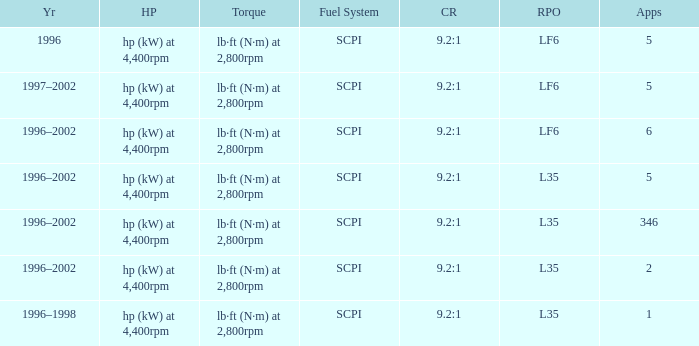What are the torque characteristics of the model made in 1996? Lb·ft (n·m) at 2,800rpm. Could you parse the entire table as a dict? {'header': ['Yr', 'HP', 'Torque', 'Fuel System', 'CR', 'RPO', 'Apps'], 'rows': [['1996', 'hp (kW) at 4,400rpm', 'lb·ft (N·m) at 2,800rpm', 'SCPI', '9.2:1', 'LF6', '5'], ['1997–2002', 'hp (kW) at 4,400rpm', 'lb·ft (N·m) at 2,800rpm', 'SCPI', '9.2:1', 'LF6', '5'], ['1996–2002', 'hp (kW) at 4,400rpm', 'lb·ft (N·m) at 2,800rpm', 'SCPI', '9.2:1', 'LF6', '6'], ['1996–2002', 'hp (kW) at 4,400rpm', 'lb·ft (N·m) at 2,800rpm', 'SCPI', '9.2:1', 'L35', '5'], ['1996–2002', 'hp (kW) at 4,400rpm', 'lb·ft (N·m) at 2,800rpm', 'SCPI', '9.2:1', 'L35', '346'], ['1996–2002', 'hp (kW) at 4,400rpm', 'lb·ft (N·m) at 2,800rpm', 'SCPI', '9.2:1', 'L35', '2'], ['1996–1998', 'hp (kW) at 4,400rpm', 'lb·ft (N·m) at 2,800rpm', 'SCPI', '9.2:1', 'L35', '1']]} 